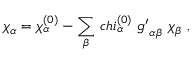<formula> <loc_0><loc_0><loc_500><loc_500>\chi _ { \alpha } = \chi _ { \alpha } ^ { ( 0 ) } - \sum _ { \beta } \, c h i _ { \alpha } ^ { ( 0 ) } \ { g ^ { \prime } } _ { \alpha \beta } \ \chi _ { \beta } \ ,</formula> 